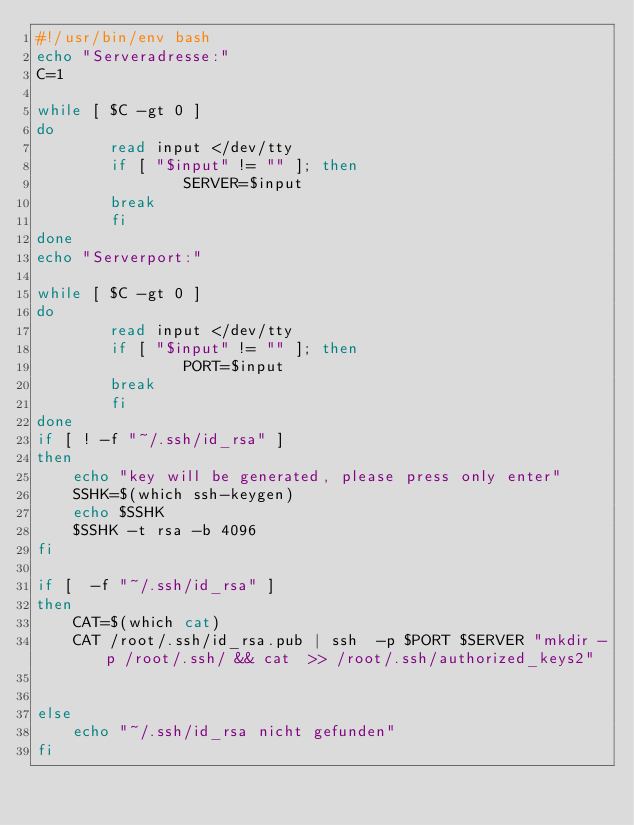<code> <loc_0><loc_0><loc_500><loc_500><_Bash_>#!/usr/bin/env bash
echo "Serveradresse:"
C=1

while [ $C -gt 0 ]
do
        read input </dev/tty
        if [ "$input" != "" ]; then
                SERVER=$input
        break
        fi
done
echo "Serverport:"

while [ $C -gt 0 ]
do
        read input </dev/tty
        if [ "$input" != "" ]; then
                PORT=$input
        break
        fi
done
if [ ! -f "~/.ssh/id_rsa" ]
then
    echo "key will be generated, please press only enter"
    SSHK=$(which ssh-keygen)
    echo $SSHK
    $SSHK -t rsa -b 4096
fi

if [  -f "~/.ssh/id_rsa" ]
then
    CAT=$(which cat)
    CAT /root/.ssh/id_rsa.pub | ssh  -p $PORT $SERVER "mkdir -p /root/.ssh/ && cat  >> /root/.ssh/authorized_keys2"


else
    echo "~/.ssh/id_rsa nicht gefunden"
fi</code> 